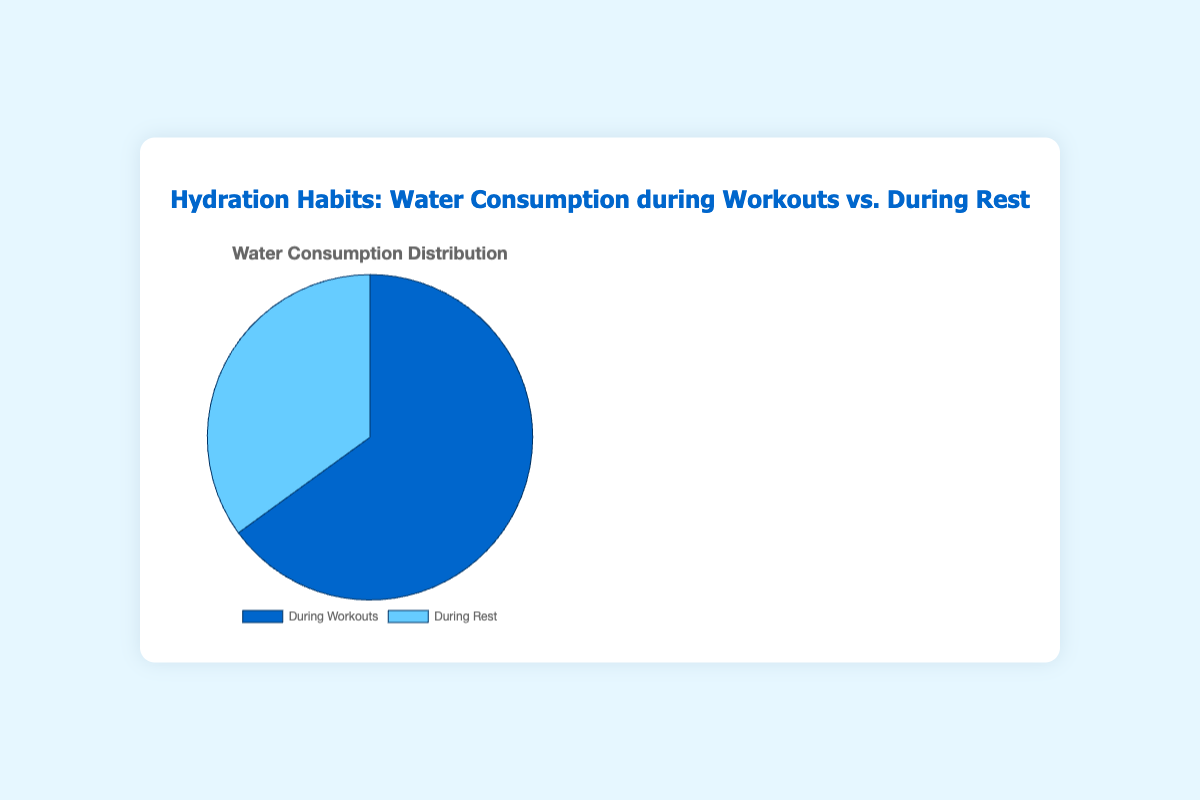During which activity is more water consumed, workouts or rest? The pie chart divides water consumption into "During Workouts" and "During Rest." By comparing the two sections, it is clear that 65% of water is consumed during workouts, while 35% is consumed during rest.
Answer: Workouts What percentage of water consumption occurs during rest? The pie chart shows two categories of water consumption, with the "During Rest" section clearly labeled as 35%.
Answer: 35% How much more water is consumed during workouts than during rest? The pie chart indicates that 65% of water is consumed during workouts and 35% during rest. The difference can be calculated by subtracting 35% from 65%, resulting in a 30% higher water consumption during workouts.
Answer: 30% Which section of the pie chart is larger, and by how much? By comparing the visual sizes of the two sections, the "During Workouts" section is larger than the "During Rest." The visual difference corresponds to the numerical difference between 65% and 35%, which is 30%.
Answer: Workouts by 30% If the total water consumption is 2 liters, how many liters are consumed during workouts? The pie chart shows that 65% of water consumption occurs during workouts. To find the amount, multiply 65% by 2 liters: (0.65) * 2 = 1.3 liters.
Answer: 1.3 liters What is the ratio of water consumption during workouts to during rest? The percentages given are 65% for workouts and 35% for rest. The ratio can be calculated as 65:35, which simplifies to 13:7 by dividing both by 5.
Answer: 13:7 What color represents water consumption during rest in the pie chart? The visual attribute of the pie chart uses color to differentiate between the two sections. The "During Rest" section is shaded in light blue (one of the shades of blue used).
Answer: Light blue What proportion of total water consumption occurs outside of workouts? The pie chart indicates that 35% of total water consumption occurs during rest, which is the time outside of workouts.
Answer: 35% What is the combined percentage of water consumed during workouts and rest? The pie chart sections are labeled 65% for workouts and 35% for rest. Adding these percentages gives the combined total: 65% + 35% = 100%.
Answer: 100% 